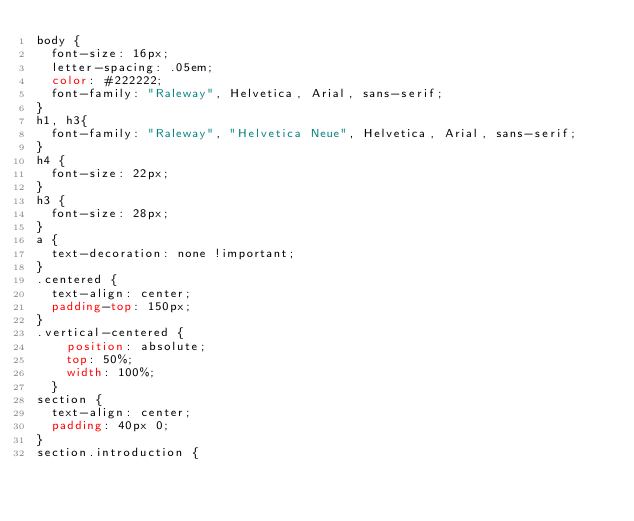Convert code to text. <code><loc_0><loc_0><loc_500><loc_500><_CSS_>body {
  font-size: 16px;
  letter-spacing: .05em;
  color: #222222;
  font-family: "Raleway", Helvetica, Arial, sans-serif;
}
h1, h3{
  font-family: "Raleway", "Helvetica Neue", Helvetica, Arial, sans-serif;
}
h4 {
  font-size: 22px;
}
h3 {
  font-size: 28px;
}
a {
  text-decoration: none !important;
}
.centered {
  text-align: center;
  padding-top: 150px;
}
.vertical-centered {
    position: absolute;
    top: 50%;
    width: 100%;
  }
section {
  text-align: center;
  padding: 40px 0;
}
section.introduction {</code> 